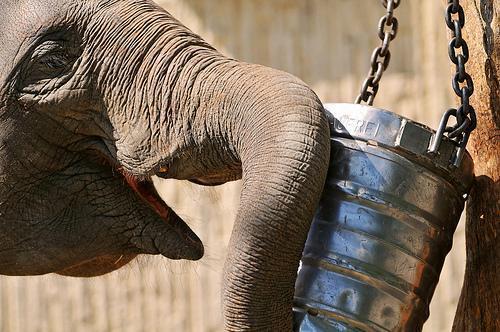How many elephants are shown?
Give a very brief answer. 1. How many buckets are there?
Give a very brief answer. 1. 